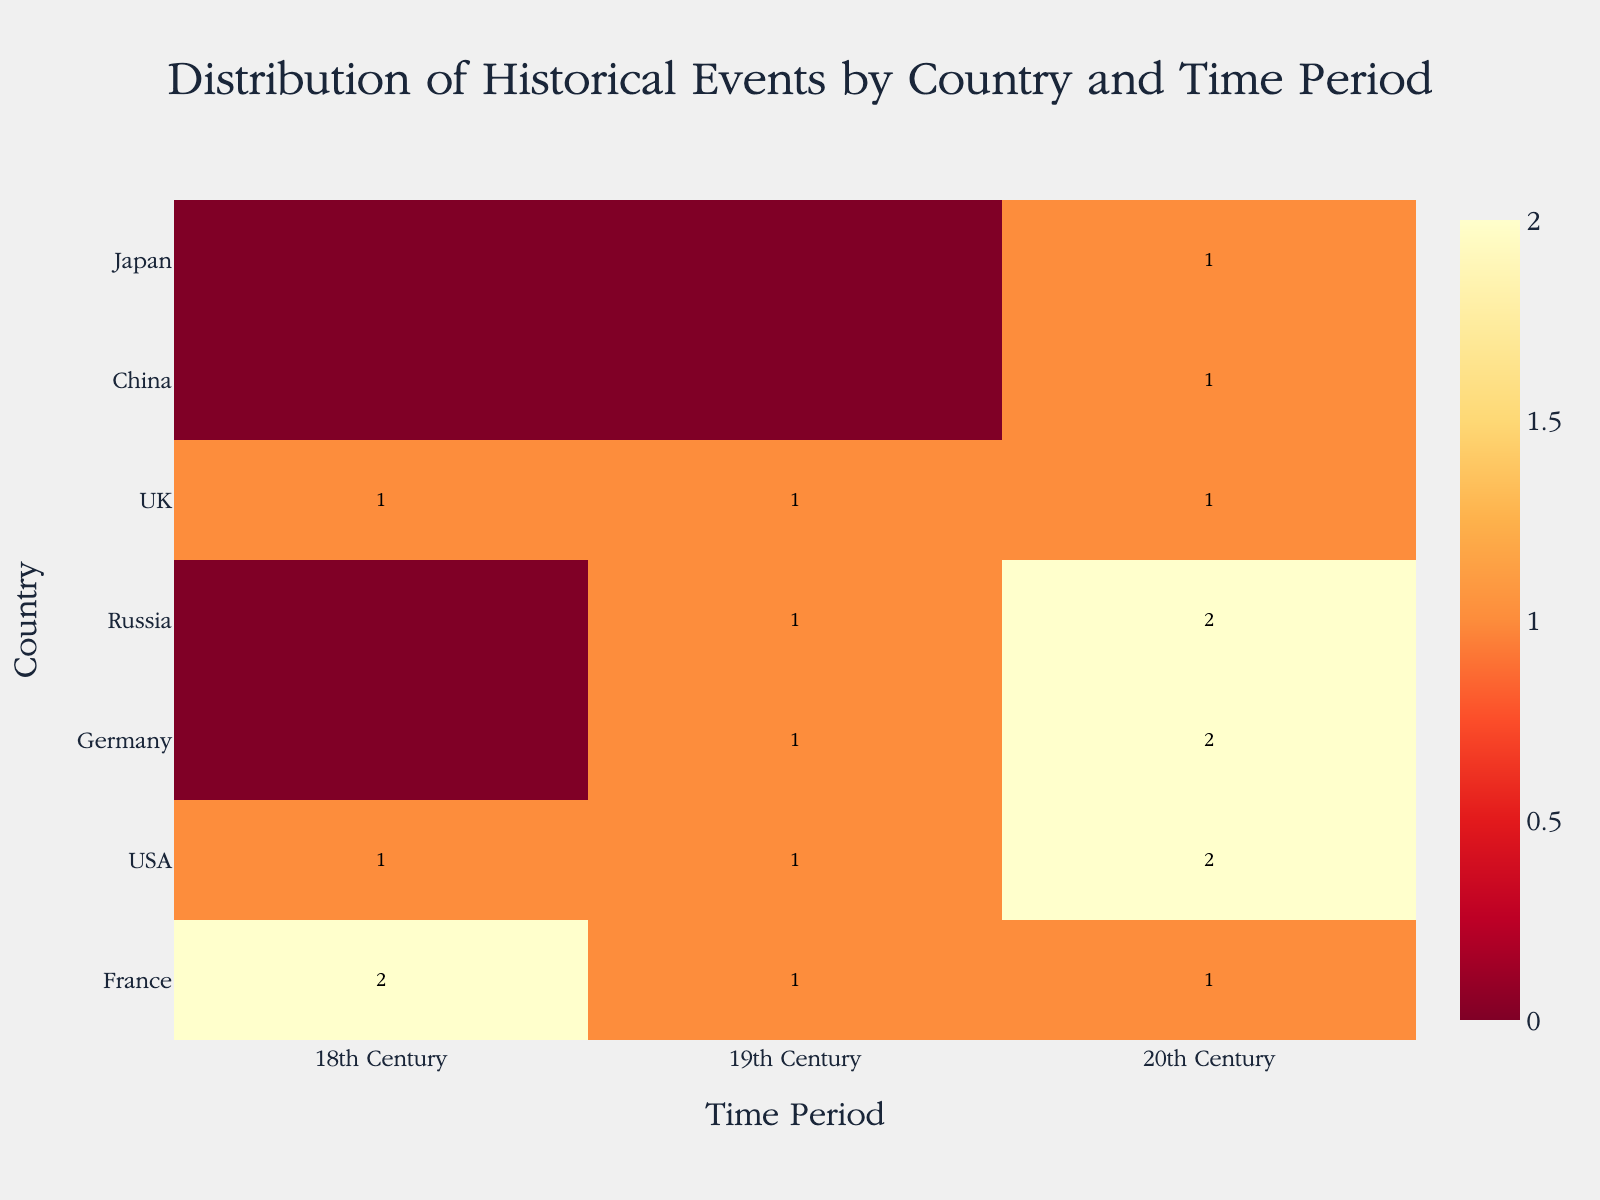How many historical events are recorded for the USA in the 20th Century? To answer this, locate the cell that intersects the row for the USA and the column for the 20th Century. Count the number of events listed.
Answer: 2 Which country has the highest number of conflicts in the 20th Century? Check the cells for each country in the 20th Century column and identify the one with the highest number of conflicts.
Answer: Germany In which time period does France have an equal number of conflicts and treaties? Look at the row for France and compare the counts of conflicts and treaties across the 18th, 19th, and 20th centuries. Identify the time period where the counts are equal.
Answer: 18th Century Which countries experienced conflicts in both the 19th and 20th Centuries? Review the rows for each country and identify the ones that have non-zero counts in the conflicts column for both the 19th and 20th centuries.
Answer: UK, Russia, Germany How many total conflicts are recorded across all countries in the 20th Century? Sum the counts of conflicts across all countries for the 20th Century.
Answer: 9 Which two countries have the same total number of historical events recorded? Compare the total number of events for each country and identify which two countries have the same total.
Answer: UK and Russia Which century has the highest variety of event types for France? Look at the row for France and compare the different event types (conflicts and treaties) listed for each century. Identify the century with the highest variety.
Answer: 20th Century How does the number of conflicts in the 18th Century compare between France and the USA? Compare the number of conflicts listed in the 18th Century for France and the USA.
Answer: Same Which country participated in the highest number of treaties in the 19th Century? Check the cells that intersect with the 19th Century and the treaties category for each country, and identify the one with the highest count.
Answer: USA Which country has events recorded in all three centuries? Identify the country or countries that have non-zero counts in the cells for the 18th, 19th, and 20th centuries.
Answer: USA 